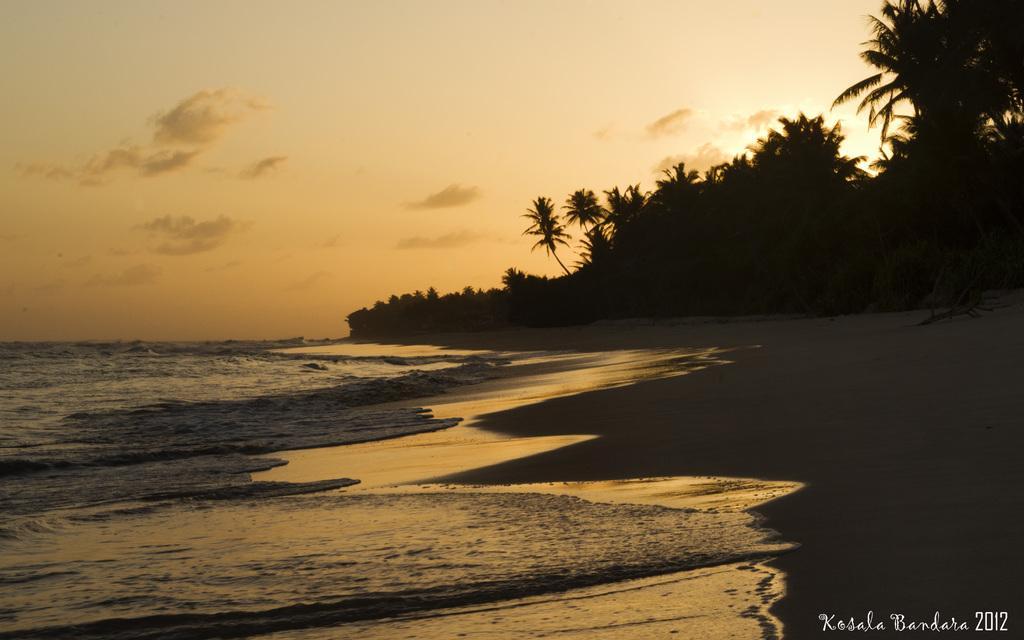Can you describe this image briefly? In this image we can see sea, seashore, trees and sky with clouds. 